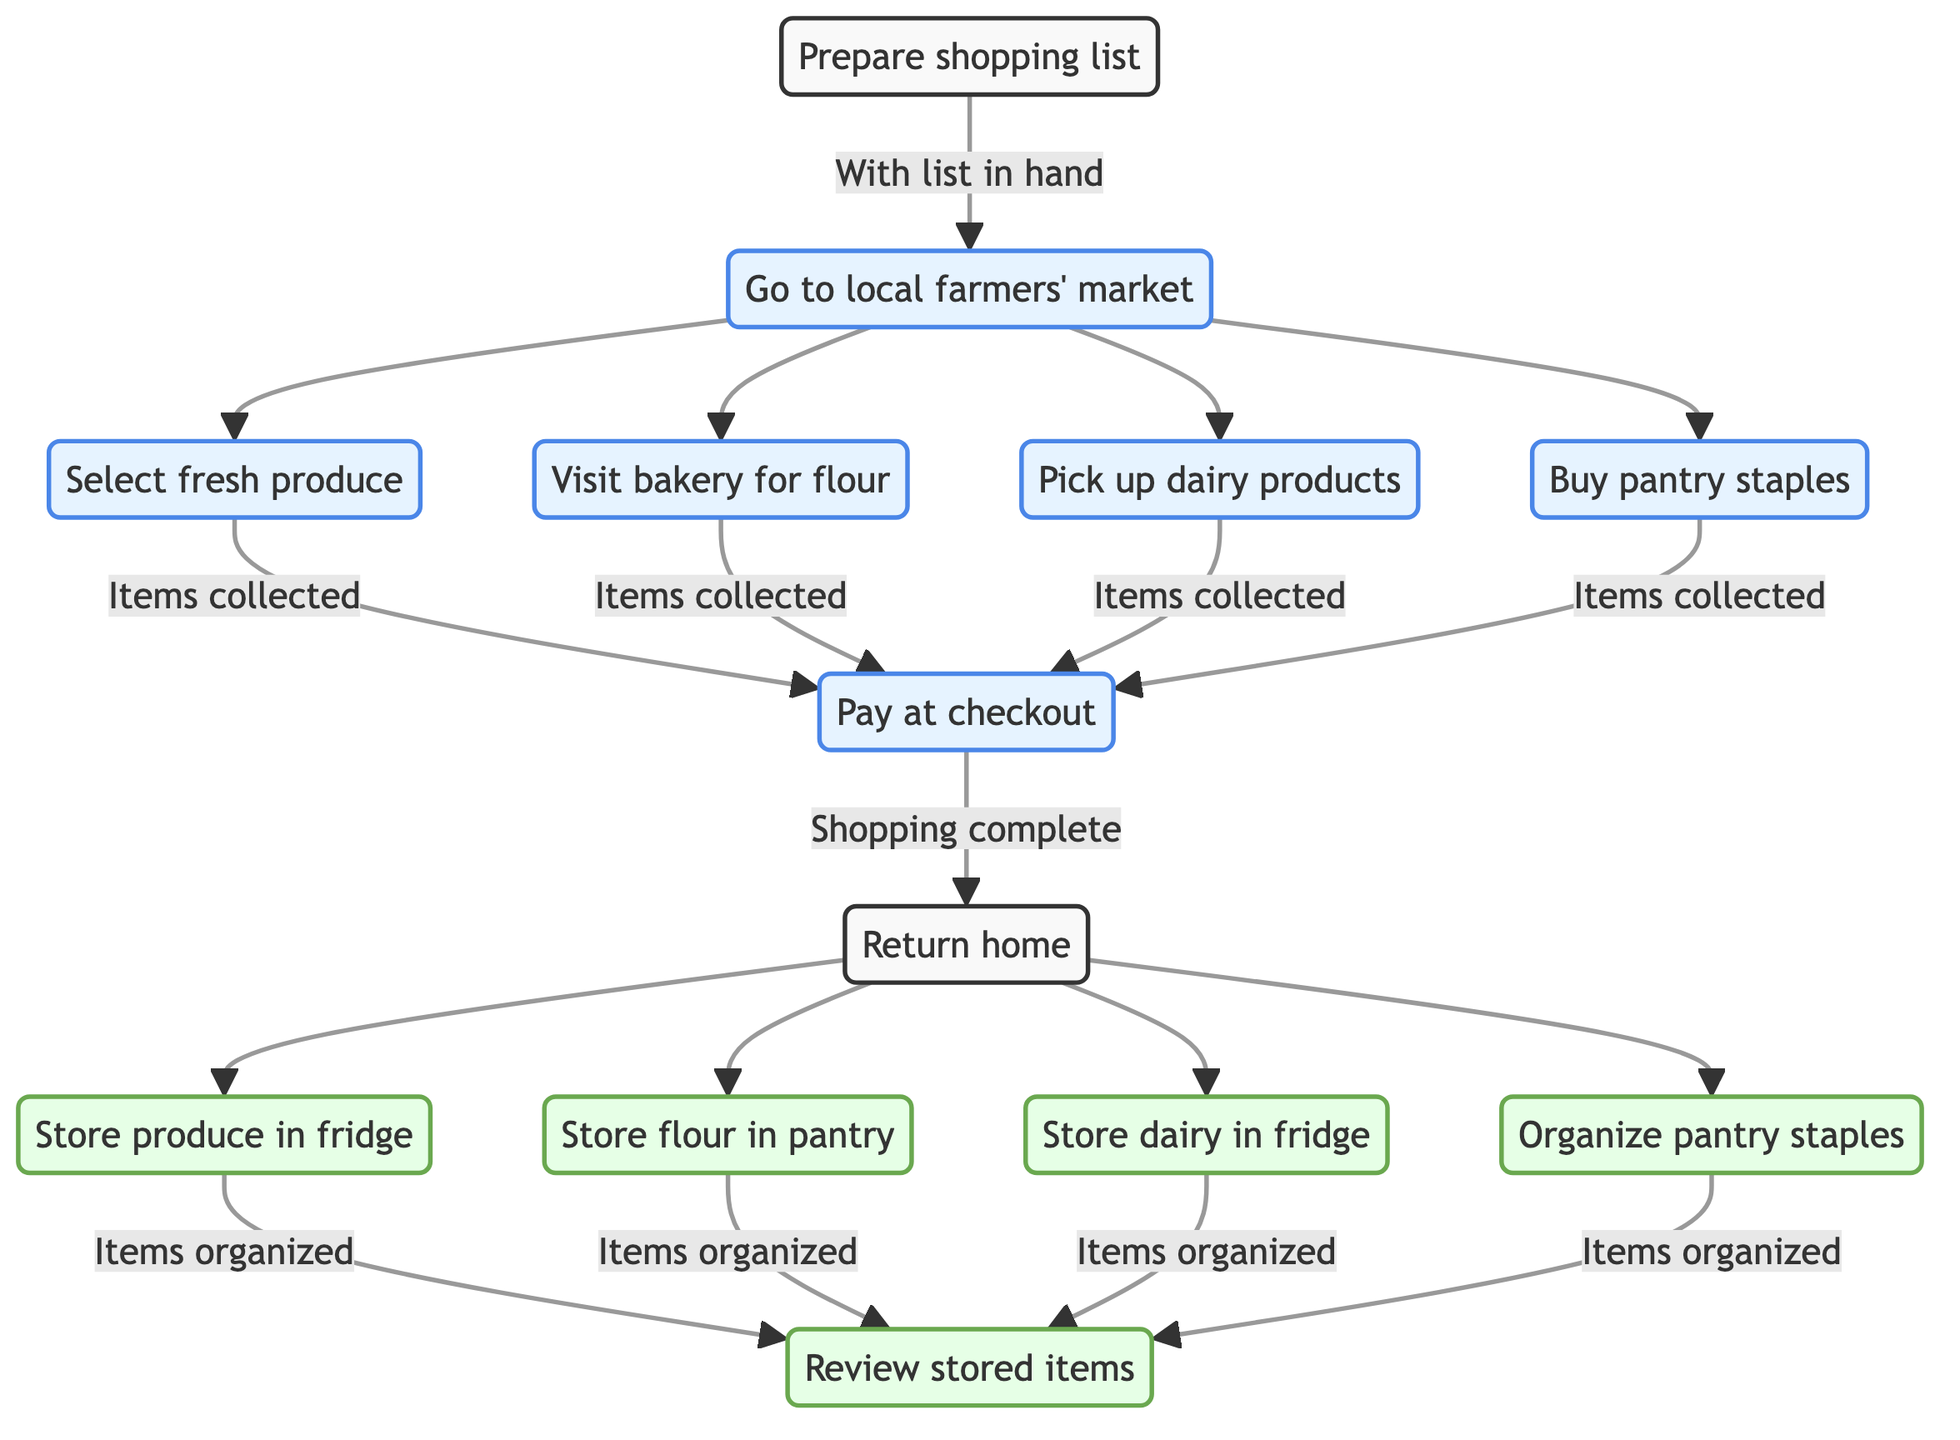What is the first step in the grocery shopping process? The diagram indicates that the first step is "Prepare shopping list," which is the starting node in the directed graph.
Answer: Prepare shopping list How many types of items are collected at the market? The diagram shows that there are four types of items collected at the farmers' market: fresh produce, flour, dairy products, and pantry staples, represented as separate nodes connected to the market visit node.
Answer: Four What happens after "Pay at checkout"? After "Pay at checkout," the next step is "Return home," which is clearly indicated as the subsequent node following the payment step.
Answer: Return home Which node is directly connected to both "Store produce in fridge" and "Store dairy in fridge"? The node "Review stored items" receives input from both "Store produce in fridge" and "Store dairy in fridge," as indicated by the outgoing edges from those nodes leading into it.
Answer: Review stored items What is the last storage action in the process? The last storage action is "Organize pantry staples," as it is the node that comes right before reviewing the stored items and is the last in the sequence of storage-related actions.
Answer: Organize pantry staples How many edges lead out of the "Go to local farmers' market" node? The "Go to local farmers' market" node has four outgoing edges, each leading to a different type of item: fresh produce, flour, dairy products, and pantry staples.
Answer: Four What is the storage method for flour? According to the diagram, flour is stored in the pantry, as indicated by the specific node that discusses this storage action.
Answer: Store flour in pantry Which node is reached after collecting all items at the market? The node reached after collecting all items is "Pay at checkout," as it is the next step following the collection of items.
Answer: Pay at checkout 